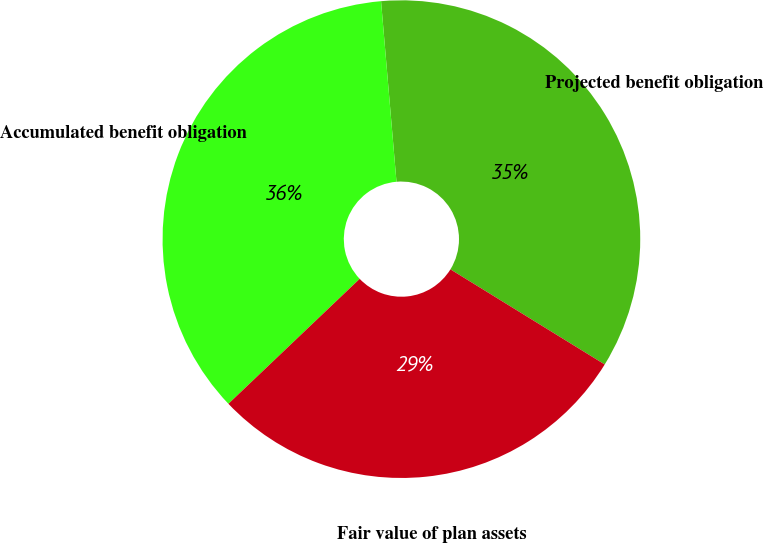Convert chart to OTSL. <chart><loc_0><loc_0><loc_500><loc_500><pie_chart><fcel>Projected benefit obligation<fcel>Accumulated benefit obligation<fcel>Fair value of plan assets<nl><fcel>35.15%<fcel>35.75%<fcel>29.1%<nl></chart> 